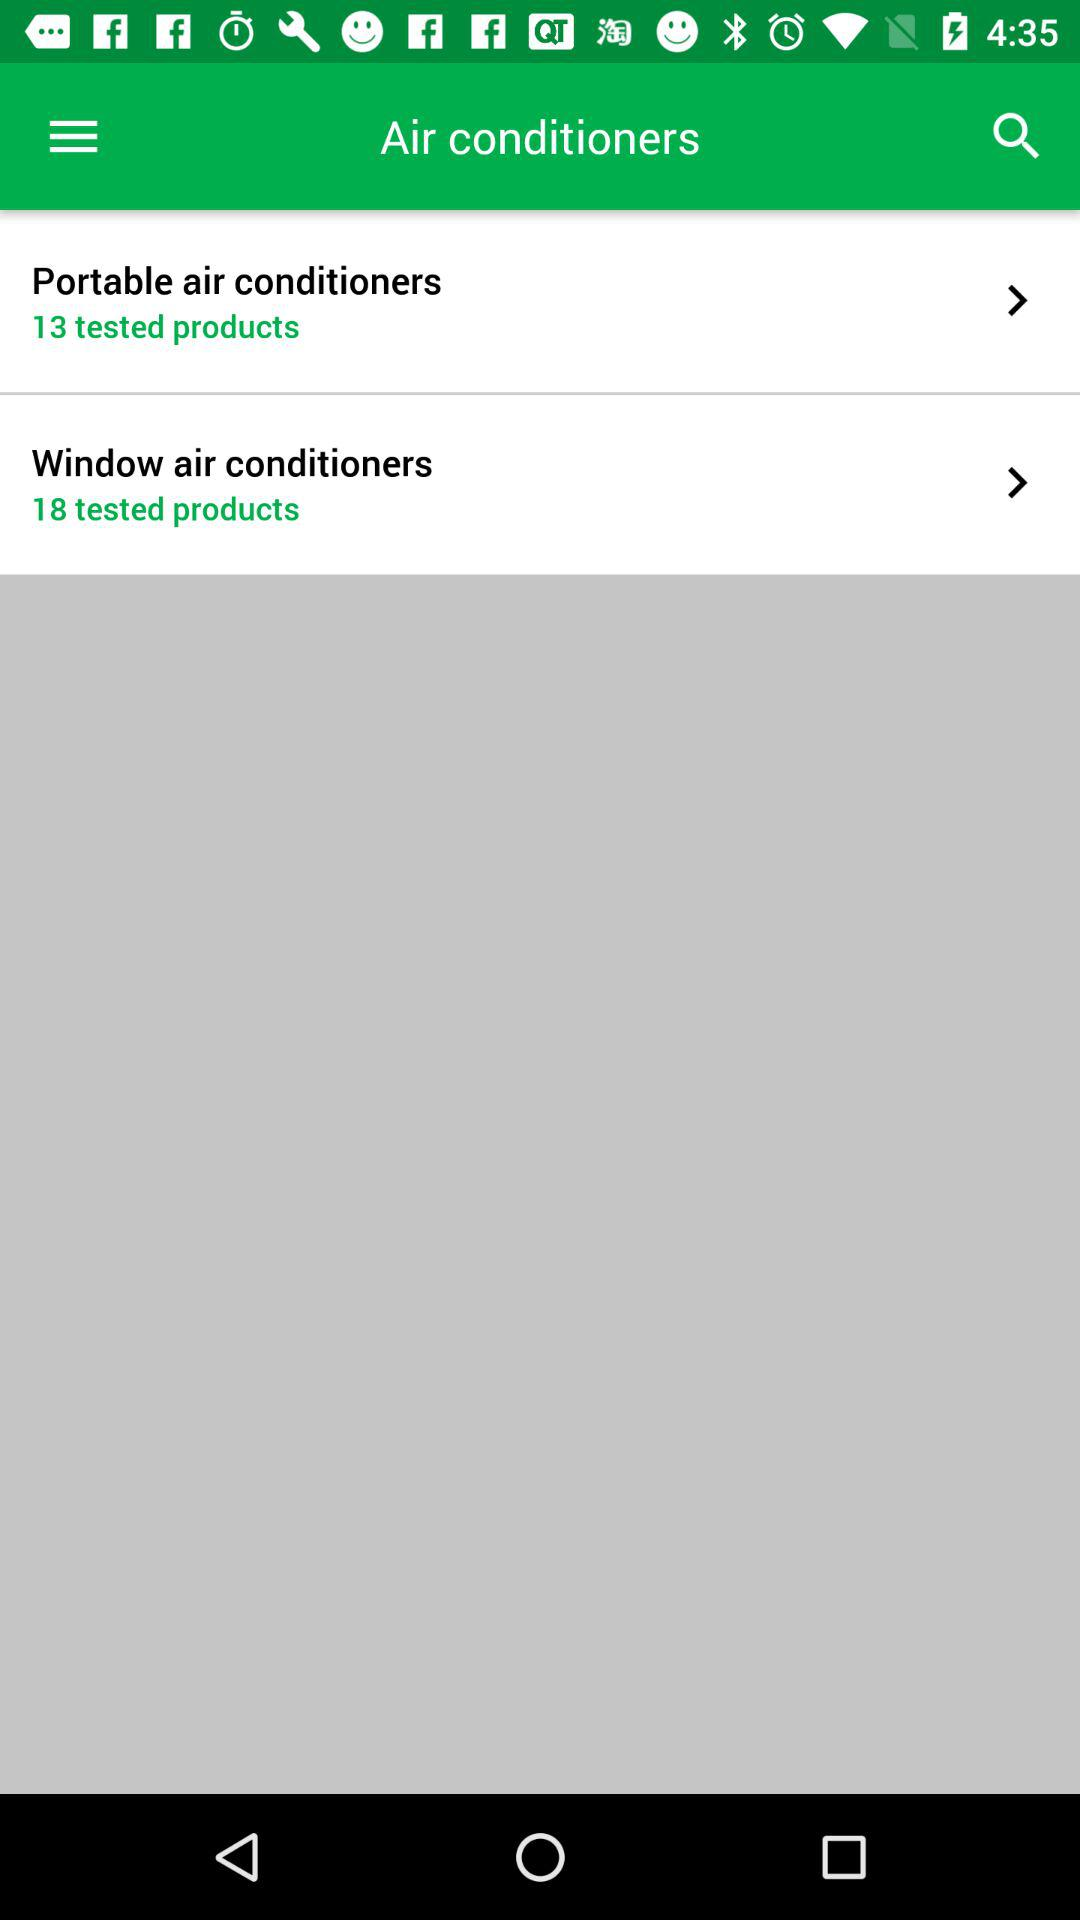How many more tested products are there for window air conditioners than portable air conditioners?
Answer the question using a single word or phrase. 5 